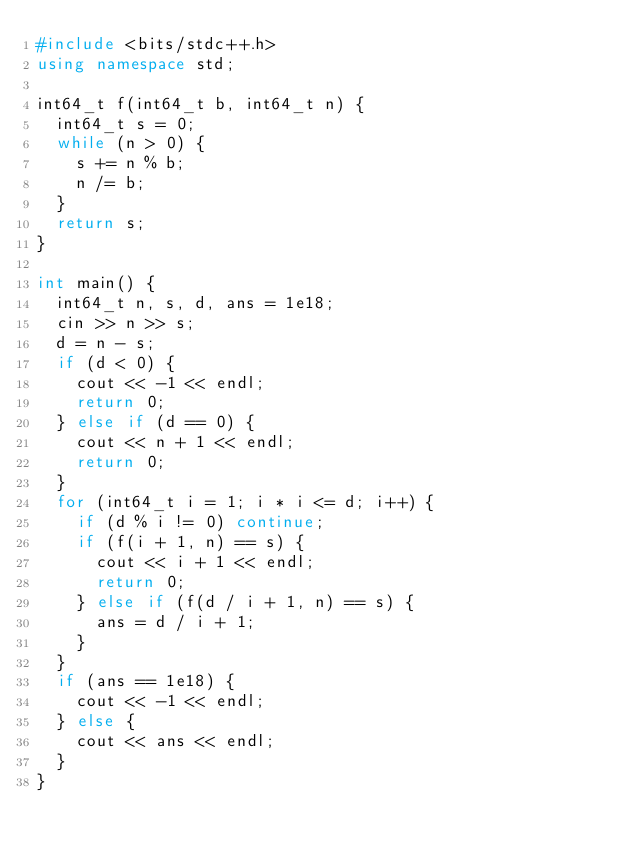Convert code to text. <code><loc_0><loc_0><loc_500><loc_500><_C++_>#include <bits/stdc++.h>
using namespace std;

int64_t f(int64_t b, int64_t n) {
  int64_t s = 0;
  while (n > 0) {
    s += n % b;
    n /= b;
  }
  return s;
}

int main() {
  int64_t n, s, d, ans = 1e18;
  cin >> n >> s;
  d = n - s;
  if (d < 0) {
    cout << -1 << endl;
    return 0;
  } else if (d == 0) {
    cout << n + 1 << endl;
    return 0;
  }
  for (int64_t i = 1; i * i <= d; i++) {
    if (d % i != 0) continue;
    if (f(i + 1, n) == s) {
      cout << i + 1 << endl;
      return 0;
    } else if (f(d / i + 1, n) == s) {
      ans = d / i + 1;
    }
  }
  if (ans == 1e18) {
    cout << -1 << endl;
  } else {
    cout << ans << endl;
  }
}
</code> 